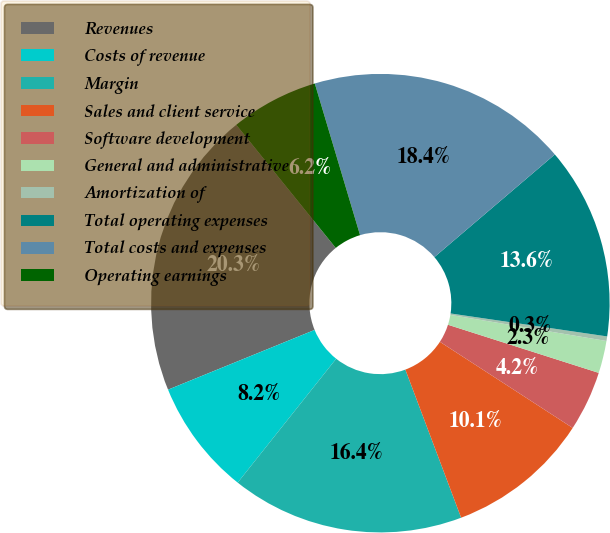Convert chart to OTSL. <chart><loc_0><loc_0><loc_500><loc_500><pie_chart><fcel>Revenues<fcel>Costs of revenue<fcel>Margin<fcel>Sales and client service<fcel>Software development<fcel>General and administrative<fcel>Amortization of<fcel>Total operating expenses<fcel>Total costs and expenses<fcel>Operating earnings<nl><fcel>20.34%<fcel>8.15%<fcel>16.42%<fcel>10.11%<fcel>4.24%<fcel>2.28%<fcel>0.32%<fcel>13.55%<fcel>18.38%<fcel>6.2%<nl></chart> 